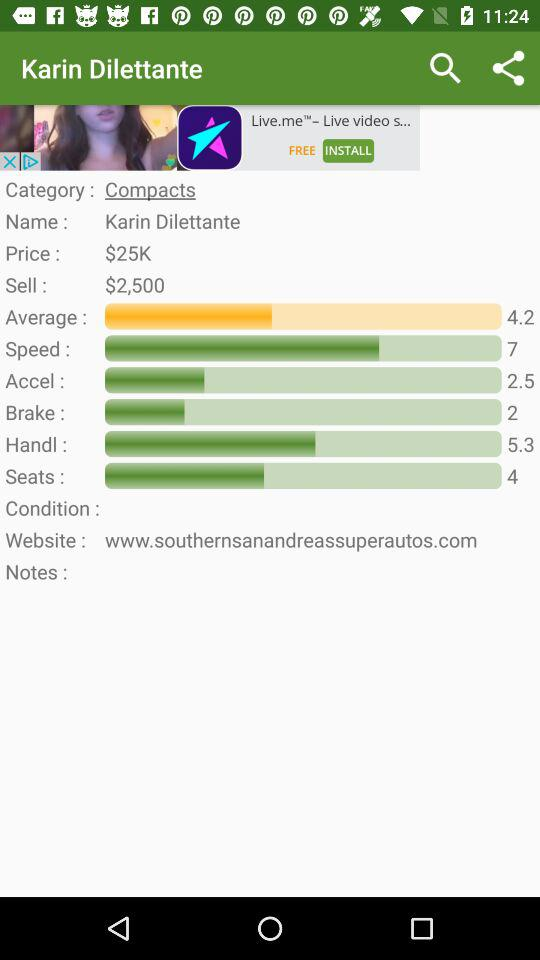What is the average rating of the Karin Dilettante?
Answer the question using a single word or phrase. 4.2 